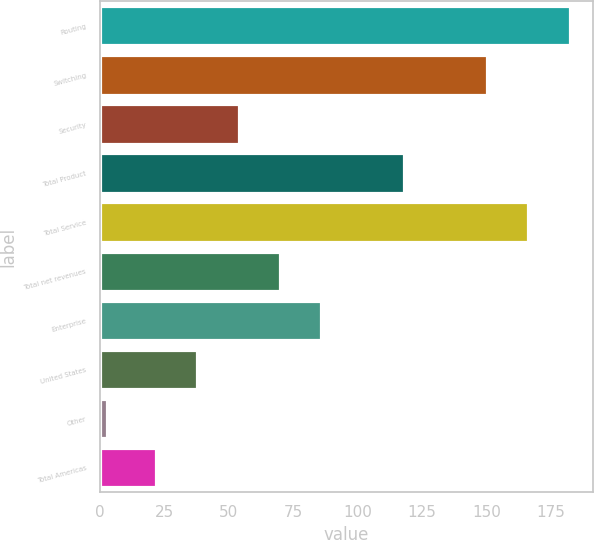Convert chart. <chart><loc_0><loc_0><loc_500><loc_500><bar_chart><fcel>Routing<fcel>Switching<fcel>Security<fcel>Total Product<fcel>Total Service<fcel>Total net revenues<fcel>Enterprise<fcel>United States<fcel>Other<fcel>Total Americas<nl><fcel>182.2<fcel>150.08<fcel>53.72<fcel>117.96<fcel>166.14<fcel>69.78<fcel>85.84<fcel>37.66<fcel>2.8<fcel>21.6<nl></chart> 